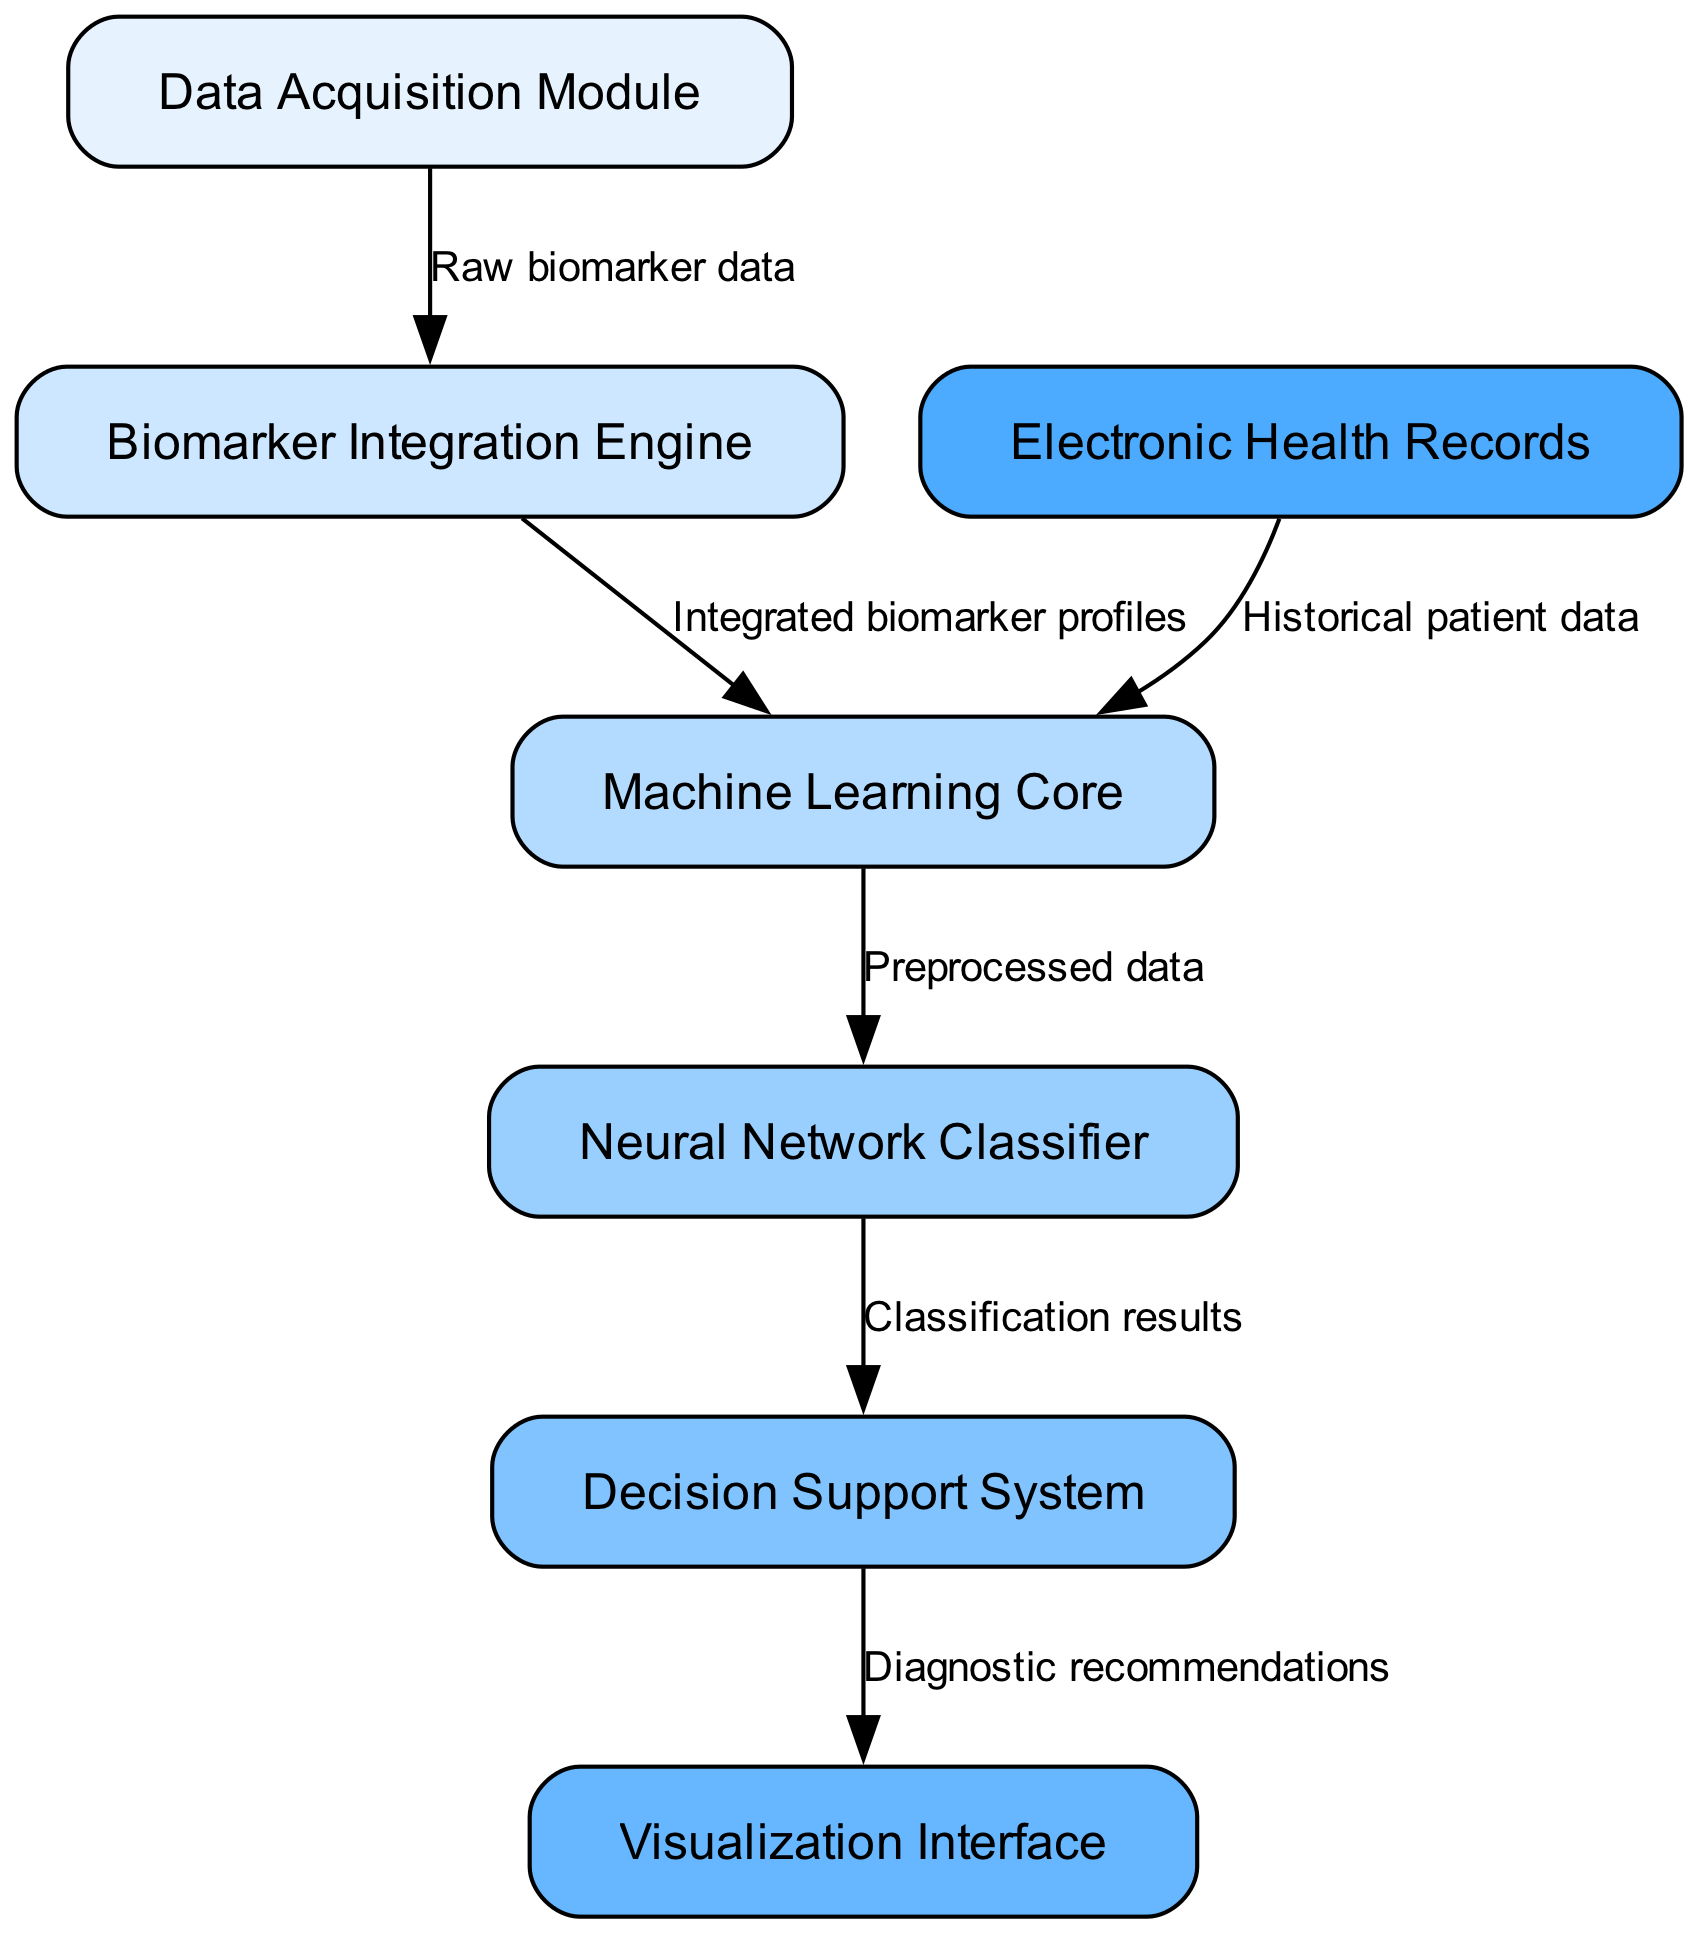What is the first module in the system architecture? The diagram lists the "Data Acquisition Module" as the first node, indicating it is the starting point of the system's process for acquiring data.
Answer: Data Acquisition Module How many nodes are in the diagram? By counting the listed nodes within the provided data, we determine there are seven distinct components, each satisfying the requirements for node representation.
Answer: Seven What type of data does the Decision Support System receive? The Decision Support System receives "Classification results," as indicated by the label on the edge connecting the Neural Network Classifier to the Decision Support System.
Answer: Classification results Which module is responsible for integrating biomarker profiles? The "Biomarker Integration Engine" is specified to accept "Raw biomarker data" from the Data Acquisition Module, meaning it plays a critical role in the integration process.
Answer: Biomarker Integration Engine What connects Electronic Health Records to the Machine Learning Core? The "Historical patient data" connects the Electronic Health Records to the Machine Learning Core, showing the flow of prior health information into the core processing unit.
Answer: Historical patient data What is the output of the Neural Network Classifier? The output is "Classification results," which the Neural Network Classifier produces as part of its processing step before transmitting to the Decision Support System.
Answer: Classification results How many edges are there in the diagram? By tallying all connections or edges described in the data, we find there are six edges connecting the various nodes of the system together, illustrating the process flow.
Answer: Six What module does the Visualization Interface receive data from? The Visualization Interface obtains data from the Decision Support System, which provides "Diagnostic recommendations" for further analysis or display.
Answer: Decision Support System 